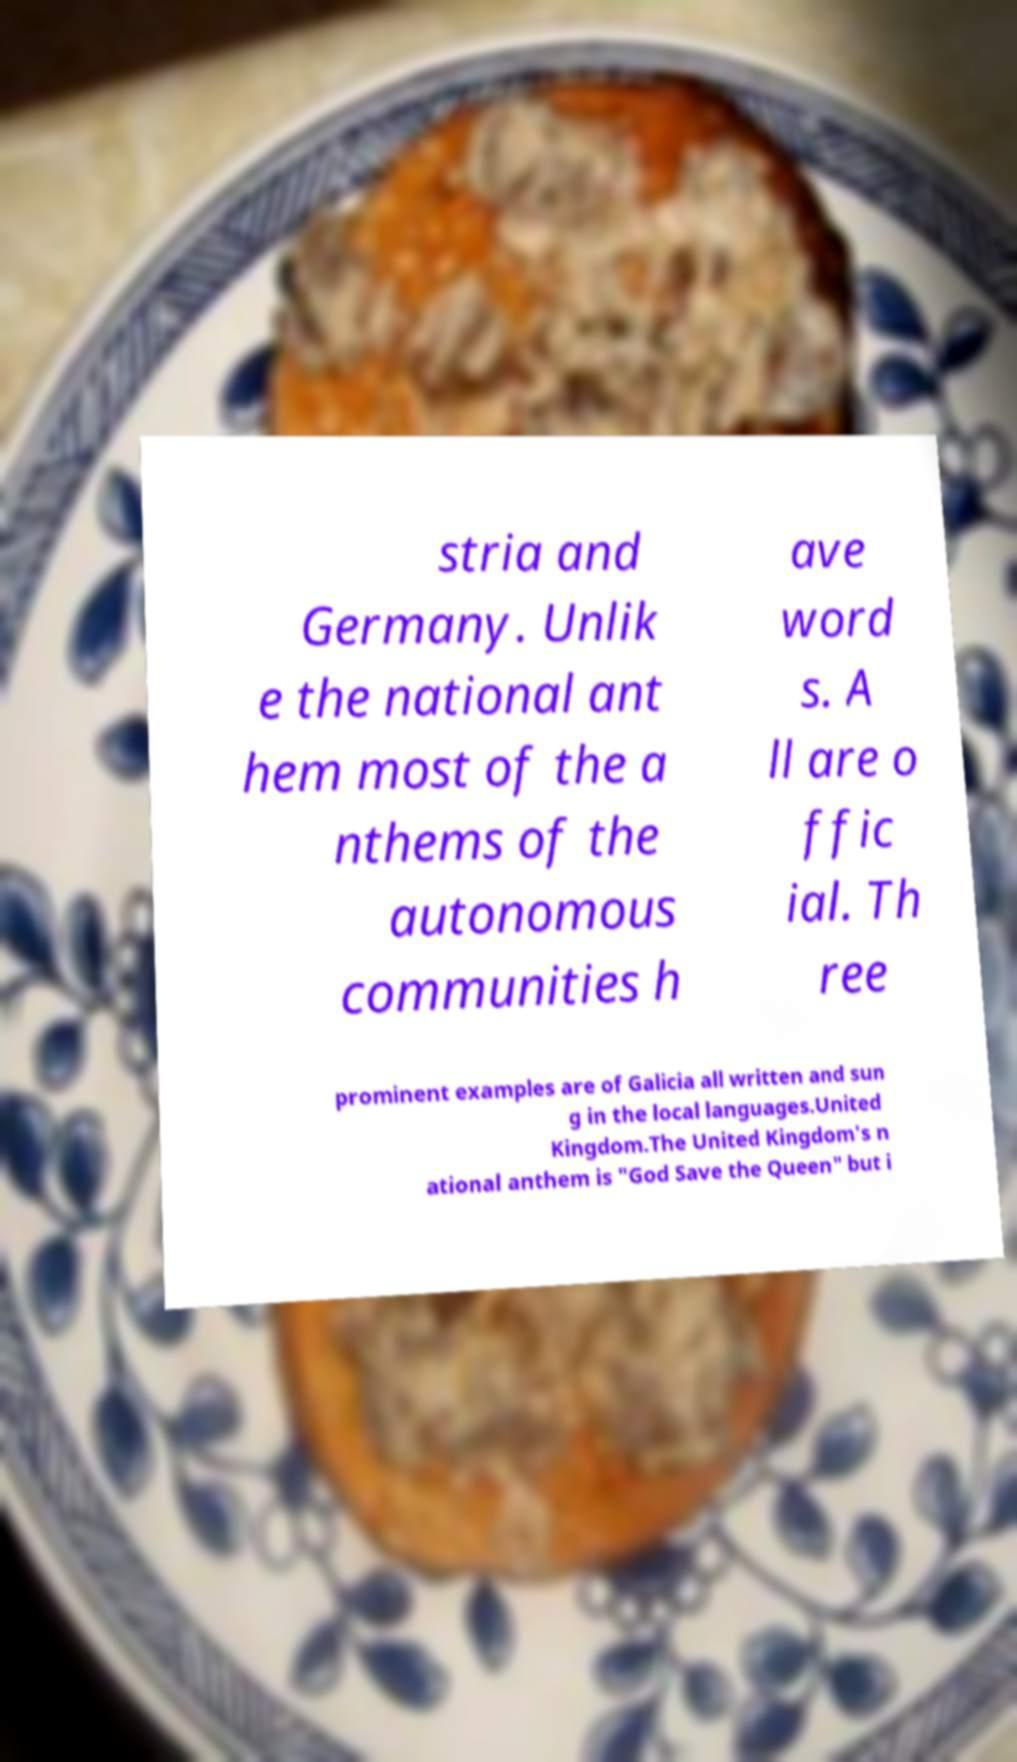Can you accurately transcribe the text from the provided image for me? stria and Germany. Unlik e the national ant hem most of the a nthems of the autonomous communities h ave word s. A ll are o ffic ial. Th ree prominent examples are of Galicia all written and sun g in the local languages.United Kingdom.The United Kingdom's n ational anthem is "God Save the Queen" but i 